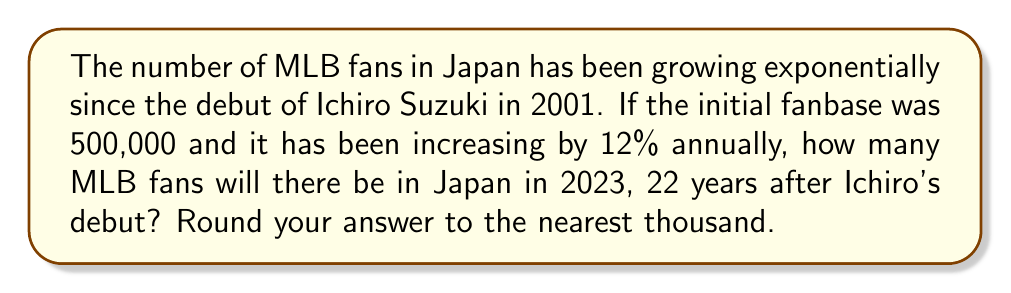Show me your answer to this math problem. Let's approach this step-by-step:

1) The initial number of fans (in 2001) is 500,000.

2) The annual growth rate is 12% or 0.12.

3) We need to calculate the number of fans after 22 years.

4) The formula for exponential growth is:

   $$A = P(1 + r)^t$$

   Where:
   $A$ = Final amount
   $P$ = Initial amount (principal)
   $r$ = Annual growth rate (as a decimal)
   $t$ = Number of years

5) Plugging in our values:

   $$A = 500,000(1 + 0.12)^{22}$$

6) Let's calculate:

   $$A = 500,000(1.12)^{22}$$
   $$A = 500,000 * 13.7858$$
   $$A = 6,892,900$$

7) Rounding to the nearest thousand:

   $$A ≈ 6,893,000$$
Answer: 6,893,000 fans 